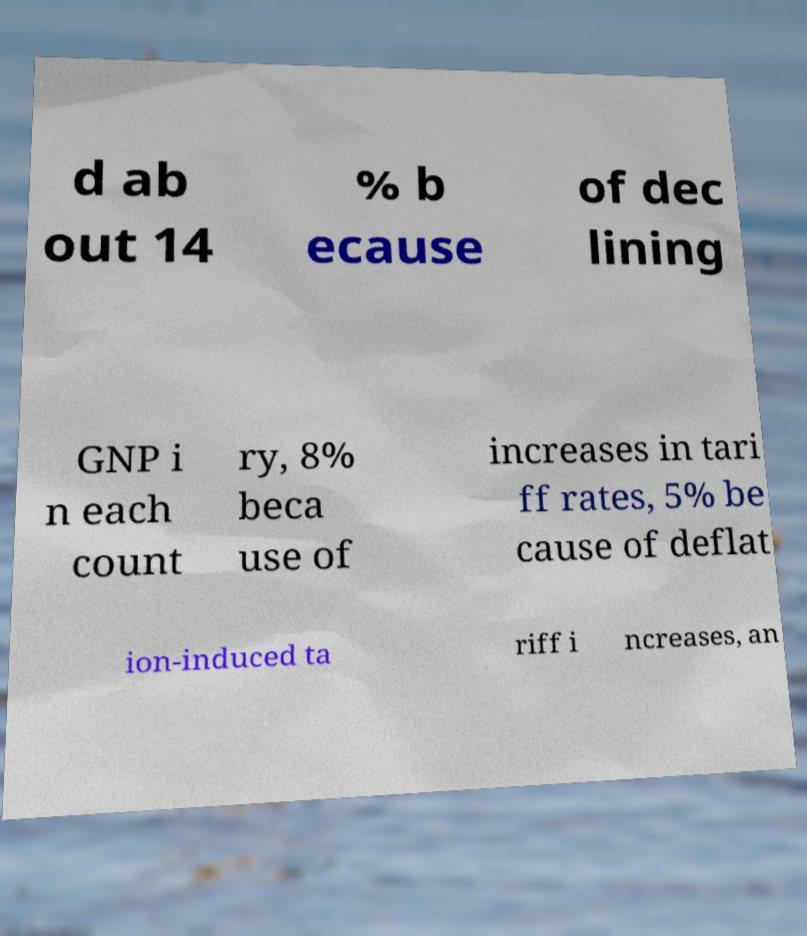For documentation purposes, I need the text within this image transcribed. Could you provide that? d ab out 14 % b ecause of dec lining GNP i n each count ry, 8% beca use of increases in tari ff rates, 5% be cause of deflat ion-induced ta riff i ncreases, an 